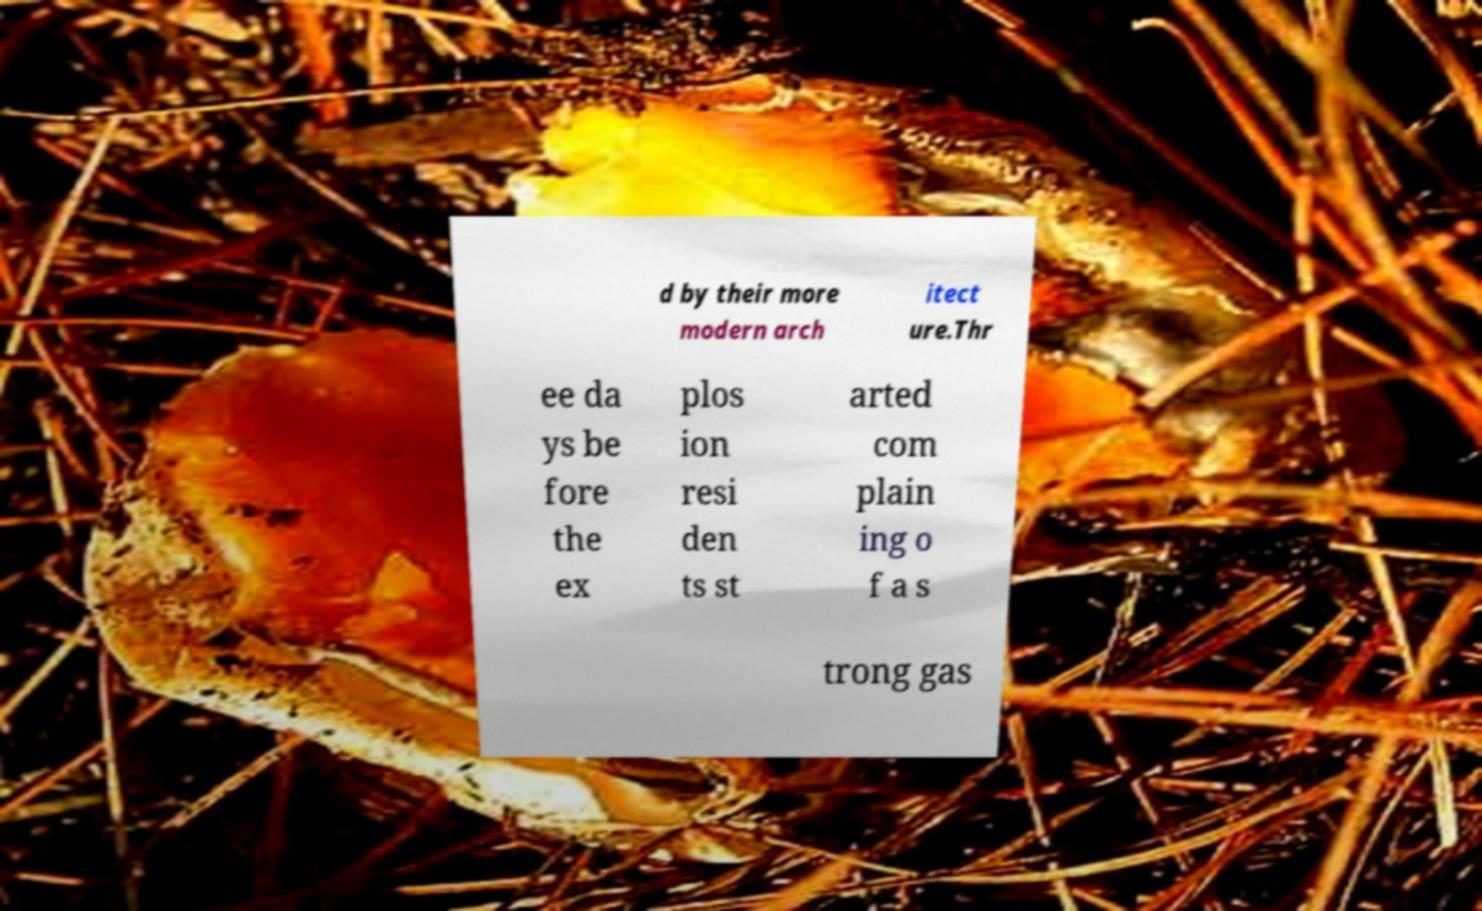Please read and relay the text visible in this image. What does it say? d by their more modern arch itect ure.Thr ee da ys be fore the ex plos ion resi den ts st arted com plain ing o f a s trong gas 